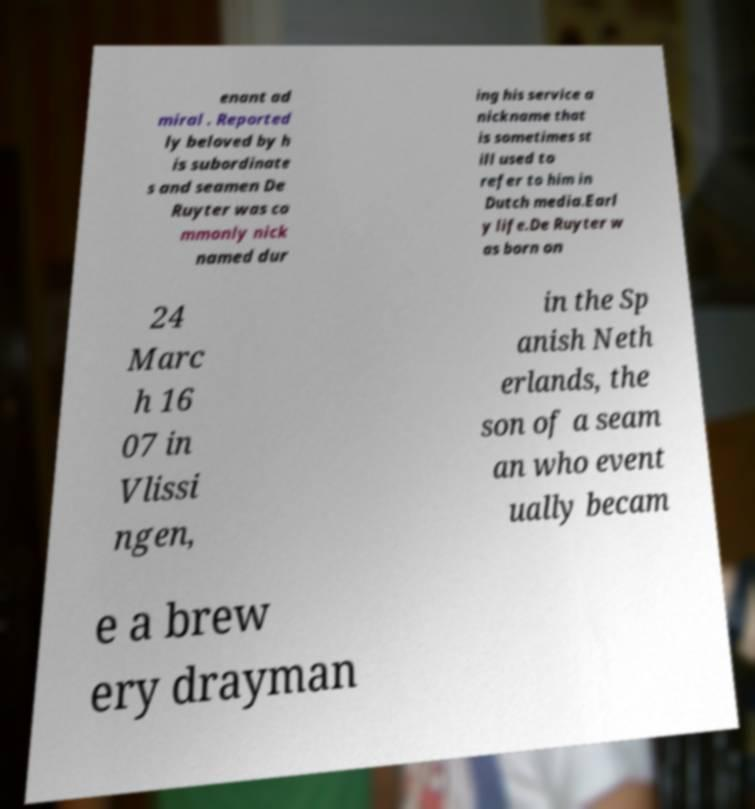Can you accurately transcribe the text from the provided image for me? enant ad miral . Reported ly beloved by h is subordinate s and seamen De Ruyter was co mmonly nick named dur ing his service a nickname that is sometimes st ill used to refer to him in Dutch media.Earl y life.De Ruyter w as born on 24 Marc h 16 07 in Vlissi ngen, in the Sp anish Neth erlands, the son of a seam an who event ually becam e a brew ery drayman 